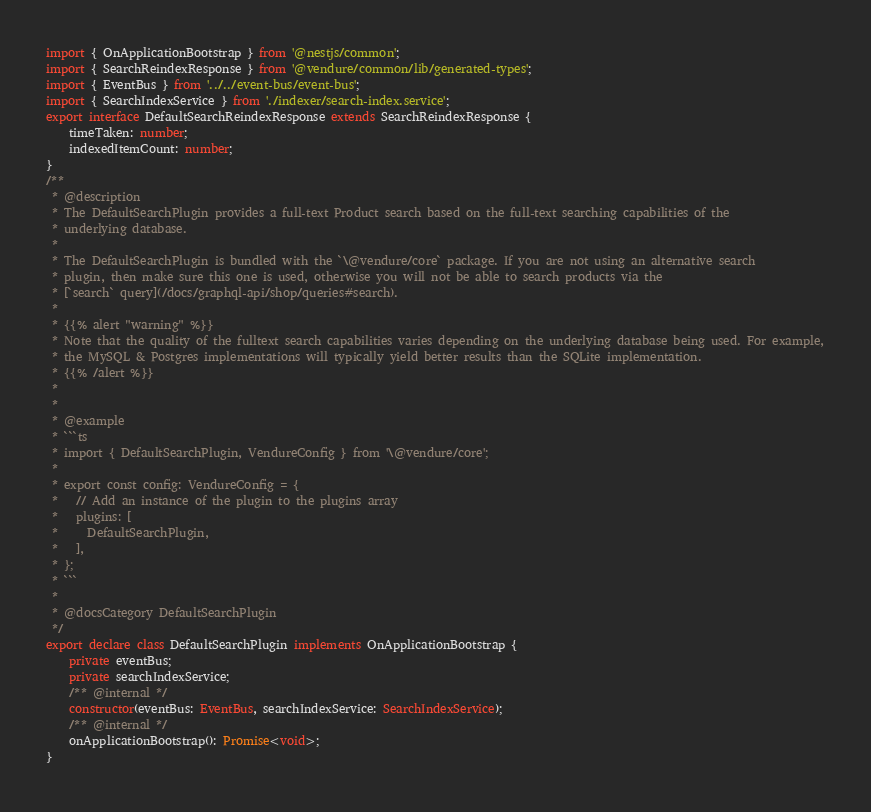<code> <loc_0><loc_0><loc_500><loc_500><_TypeScript_>import { OnApplicationBootstrap } from '@nestjs/common';
import { SearchReindexResponse } from '@vendure/common/lib/generated-types';
import { EventBus } from '../../event-bus/event-bus';
import { SearchIndexService } from './indexer/search-index.service';
export interface DefaultSearchReindexResponse extends SearchReindexResponse {
    timeTaken: number;
    indexedItemCount: number;
}
/**
 * @description
 * The DefaultSearchPlugin provides a full-text Product search based on the full-text searching capabilities of the
 * underlying database.
 *
 * The DefaultSearchPlugin is bundled with the `\@vendure/core` package. If you are not using an alternative search
 * plugin, then make sure this one is used, otherwise you will not be able to search products via the
 * [`search` query](/docs/graphql-api/shop/queries#search).
 *
 * {{% alert "warning" %}}
 * Note that the quality of the fulltext search capabilities varies depending on the underlying database being used. For example,
 * the MySQL & Postgres implementations will typically yield better results than the SQLite implementation.
 * {{% /alert %}}
 *
 *
 * @example
 * ```ts
 * import { DefaultSearchPlugin, VendureConfig } from '\@vendure/core';
 *
 * export const config: VendureConfig = {
 *   // Add an instance of the plugin to the plugins array
 *   plugins: [
 *     DefaultSearchPlugin,
 *   ],
 * };
 * ```
 *
 * @docsCategory DefaultSearchPlugin
 */
export declare class DefaultSearchPlugin implements OnApplicationBootstrap {
    private eventBus;
    private searchIndexService;
    /** @internal */
    constructor(eventBus: EventBus, searchIndexService: SearchIndexService);
    /** @internal */
    onApplicationBootstrap(): Promise<void>;
}
</code> 